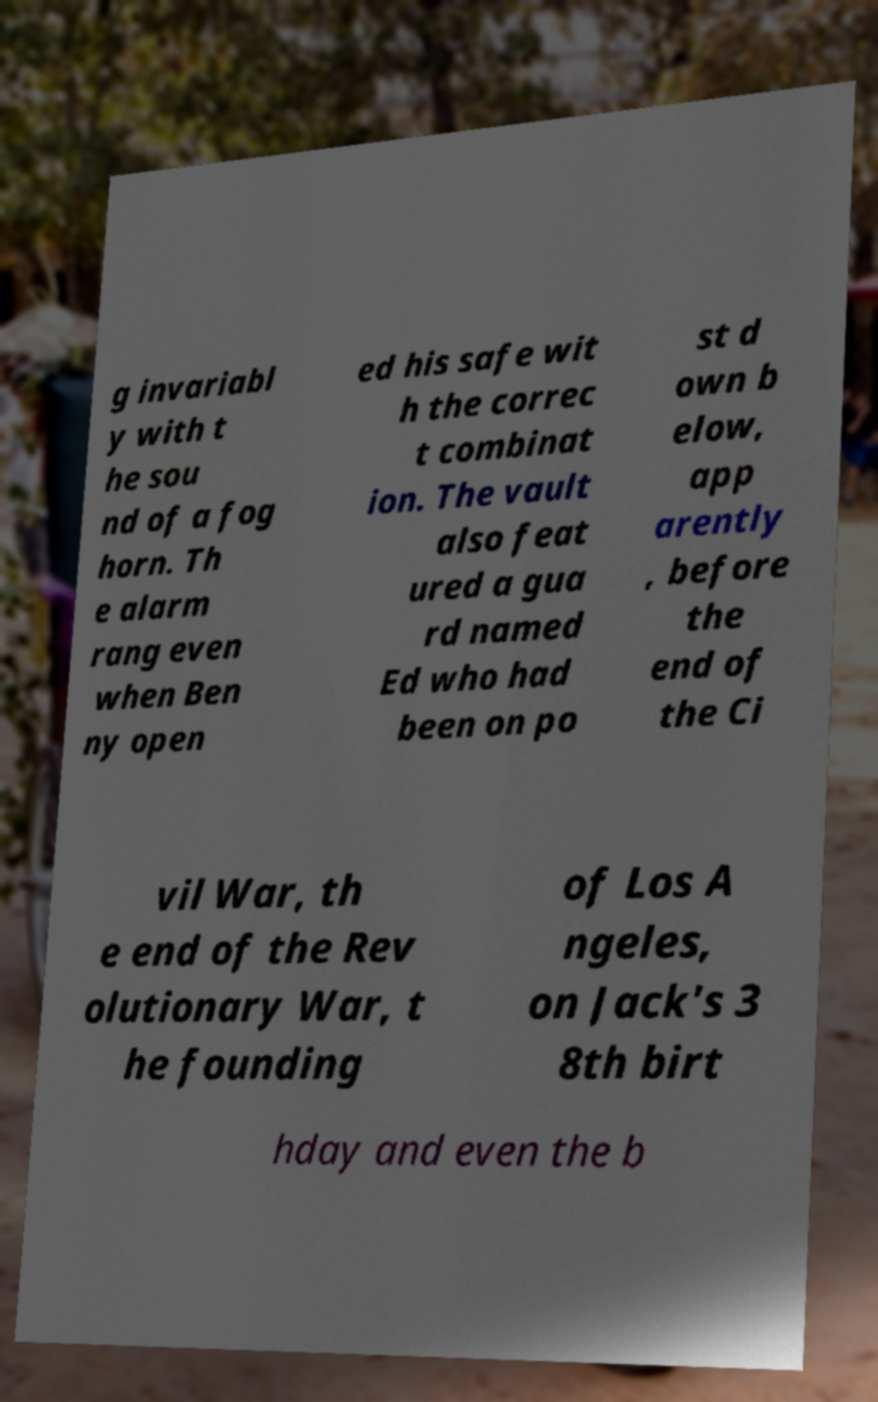Can you read and provide the text displayed in the image?This photo seems to have some interesting text. Can you extract and type it out for me? g invariabl y with t he sou nd of a fog horn. Th e alarm rang even when Ben ny open ed his safe wit h the correc t combinat ion. The vault also feat ured a gua rd named Ed who had been on po st d own b elow, app arently , before the end of the Ci vil War, th e end of the Rev olutionary War, t he founding of Los A ngeles, on Jack's 3 8th birt hday and even the b 